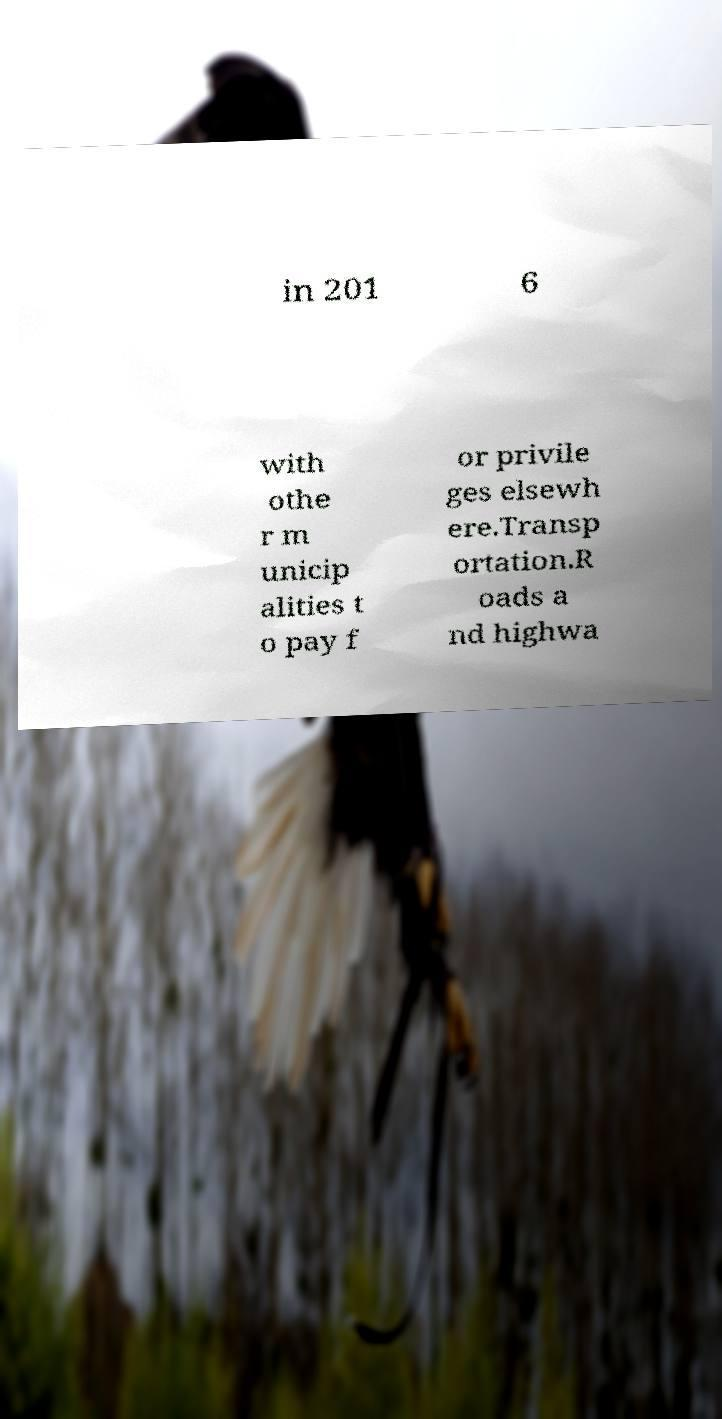Could you assist in decoding the text presented in this image and type it out clearly? in 201 6 with othe r m unicip alities t o pay f or privile ges elsewh ere.Transp ortation.R oads a nd highwa 